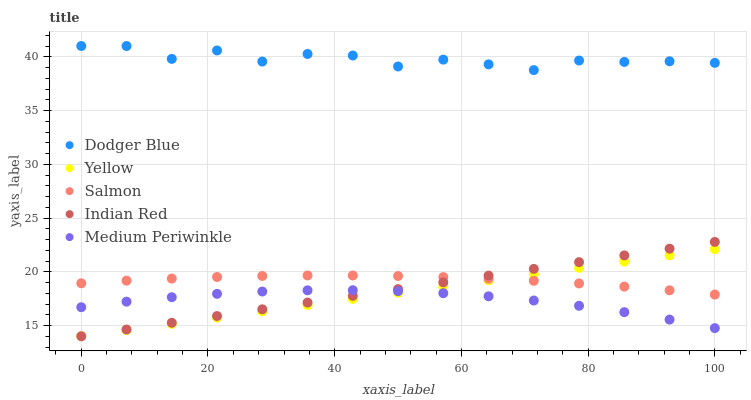Does Medium Periwinkle have the minimum area under the curve?
Answer yes or no. Yes. Does Dodger Blue have the maximum area under the curve?
Answer yes or no. Yes. Does Indian Red have the minimum area under the curve?
Answer yes or no. No. Does Indian Red have the maximum area under the curve?
Answer yes or no. No. Is Yellow the smoothest?
Answer yes or no. Yes. Is Dodger Blue the roughest?
Answer yes or no. Yes. Is Indian Red the smoothest?
Answer yes or no. No. Is Indian Red the roughest?
Answer yes or no. No. Does Indian Red have the lowest value?
Answer yes or no. Yes. Does Dodger Blue have the lowest value?
Answer yes or no. No. Does Dodger Blue have the highest value?
Answer yes or no. Yes. Does Indian Red have the highest value?
Answer yes or no. No. Is Medium Periwinkle less than Salmon?
Answer yes or no. Yes. Is Salmon greater than Medium Periwinkle?
Answer yes or no. Yes. Does Yellow intersect Indian Red?
Answer yes or no. Yes. Is Yellow less than Indian Red?
Answer yes or no. No. Is Yellow greater than Indian Red?
Answer yes or no. No. Does Medium Periwinkle intersect Salmon?
Answer yes or no. No. 